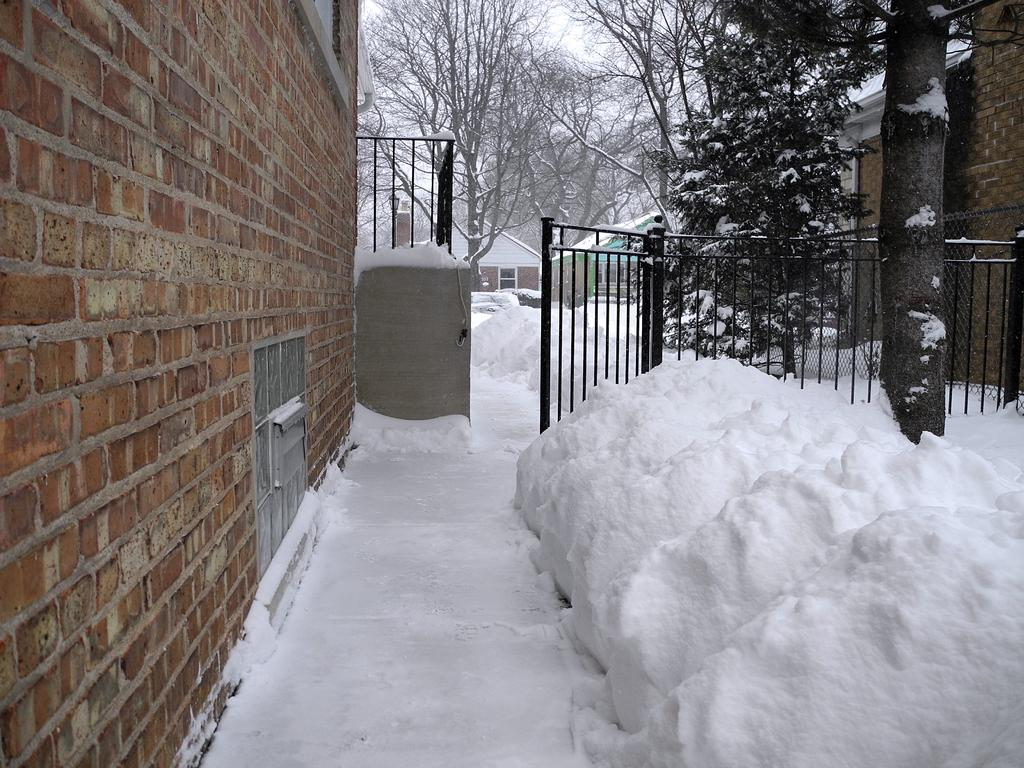What is located on the left side of the image? There is a wall on the left side of the image. What can be seen in the background of the image? There are sheds, trees, grilles, and a mesh in the background of the image. How is the entire scene depicted in the image? All of these elements are covered by snow. Can you describe the ground in the image? There is snow at the bottom of the image. What type of detail can be seen on the wall in the image? There is no specific detail mentioned on the wall in the provided facts, so it cannot be determined from the image. Is this image taken in a park? The provided facts do not mention any park or park-related elements, so it cannot be determined from the image. 